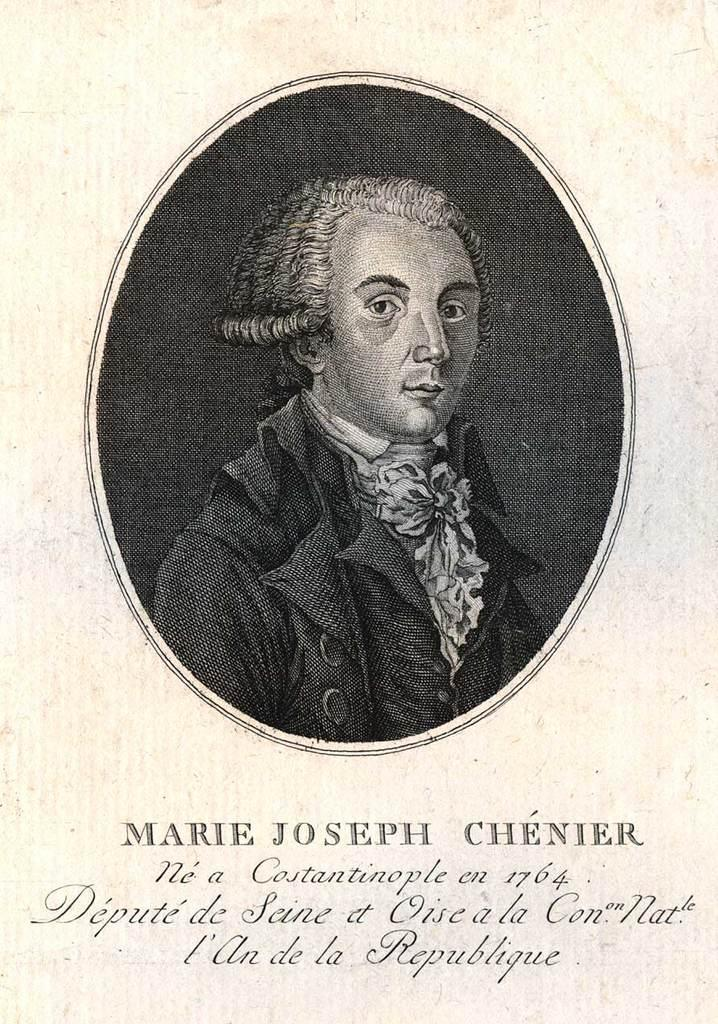What type of image is on the paper? The paper contains a black and white picture of a person. What else can be found on the paper besides the image? There are letters on the paper. How many teeth can be seen in the picture on the paper? There are no teeth visible in the picture on the paper, as it is a black and white image of a person. 